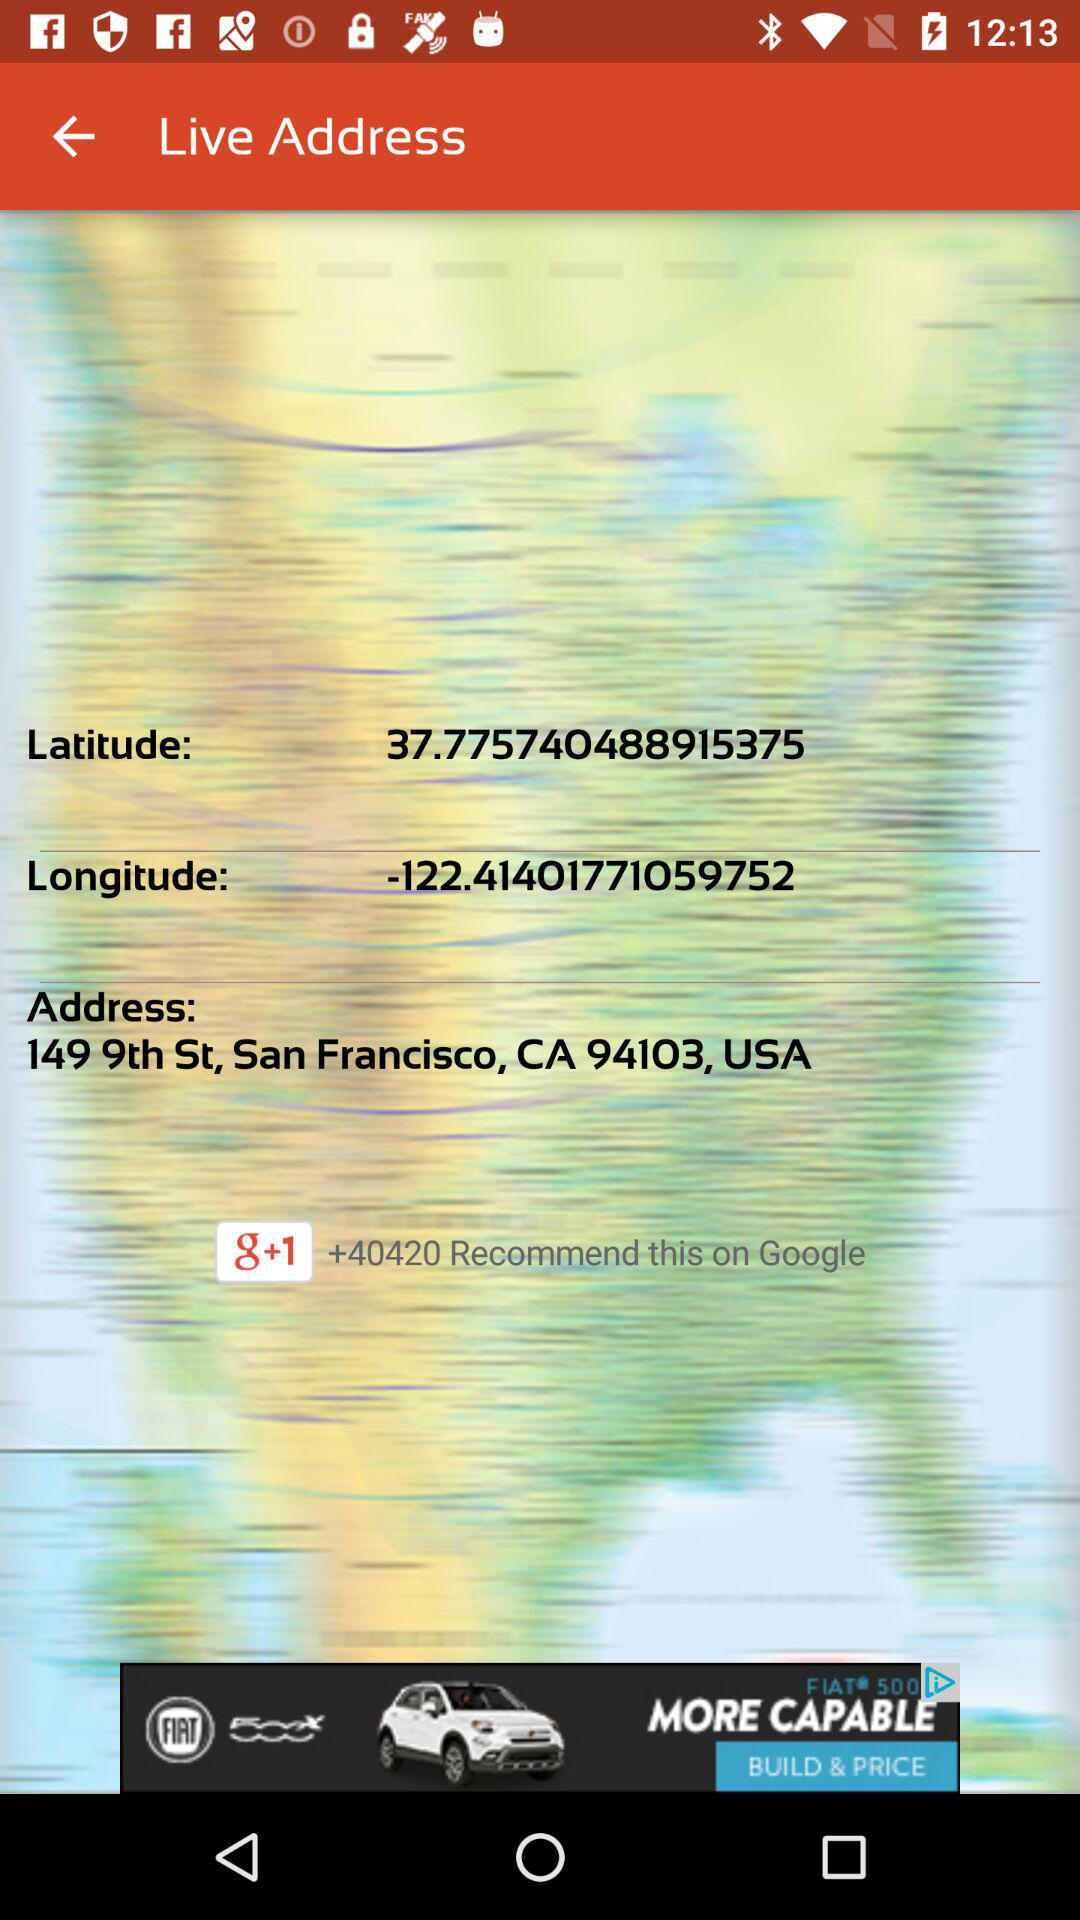What is the mentioned address? The mentioned address is 149 9th St., San Francisco, CA 94103, USA. 